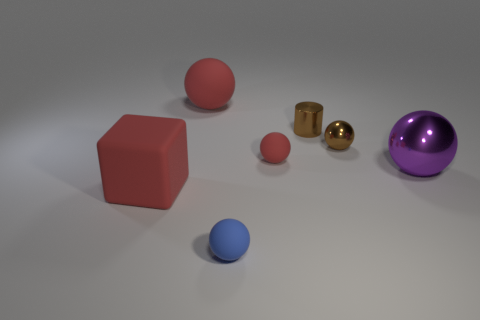The small matte thing that is behind the tiny blue rubber sphere has what shape? The small matte object located behind the tiny blue rubber sphere is a red cube. It has six faces, with each face being a square, and all its edges are of equal length. 